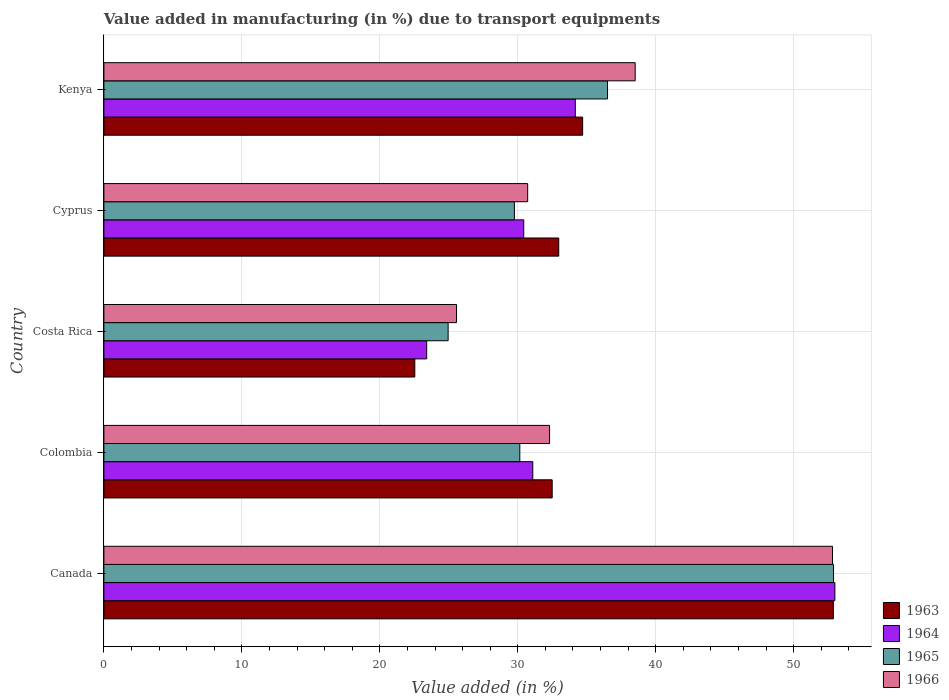Are the number of bars per tick equal to the number of legend labels?
Provide a short and direct response. Yes. How many bars are there on the 5th tick from the top?
Your answer should be very brief. 4. In how many cases, is the number of bars for a given country not equal to the number of legend labels?
Offer a terse response. 0. What is the percentage of value added in manufacturing due to transport equipments in 1965 in Kenya?
Offer a very short reply. 36.5. Across all countries, what is the maximum percentage of value added in manufacturing due to transport equipments in 1965?
Offer a terse response. 52.89. Across all countries, what is the minimum percentage of value added in manufacturing due to transport equipments in 1963?
Give a very brief answer. 22.53. What is the total percentage of value added in manufacturing due to transport equipments in 1965 in the graph?
Ensure brevity in your answer.  174.24. What is the difference between the percentage of value added in manufacturing due to transport equipments in 1965 in Canada and that in Kenya?
Your response must be concise. 16.38. What is the difference between the percentage of value added in manufacturing due to transport equipments in 1964 in Colombia and the percentage of value added in manufacturing due to transport equipments in 1965 in Kenya?
Your response must be concise. -5.42. What is the average percentage of value added in manufacturing due to transport equipments in 1966 per country?
Make the answer very short. 35.98. What is the difference between the percentage of value added in manufacturing due to transport equipments in 1963 and percentage of value added in manufacturing due to transport equipments in 1965 in Canada?
Your answer should be very brief. -0.01. In how many countries, is the percentage of value added in manufacturing due to transport equipments in 1963 greater than 10 %?
Keep it short and to the point. 5. What is the ratio of the percentage of value added in manufacturing due to transport equipments in 1966 in Canada to that in Kenya?
Your answer should be very brief. 1.37. Is the percentage of value added in manufacturing due to transport equipments in 1966 in Colombia less than that in Cyprus?
Offer a very short reply. No. What is the difference between the highest and the second highest percentage of value added in manufacturing due to transport equipments in 1965?
Offer a terse response. 16.38. What is the difference between the highest and the lowest percentage of value added in manufacturing due to transport equipments in 1966?
Provide a short and direct response. 27.25. In how many countries, is the percentage of value added in manufacturing due to transport equipments in 1965 greater than the average percentage of value added in manufacturing due to transport equipments in 1965 taken over all countries?
Offer a very short reply. 2. Is it the case that in every country, the sum of the percentage of value added in manufacturing due to transport equipments in 1965 and percentage of value added in manufacturing due to transport equipments in 1964 is greater than the sum of percentage of value added in manufacturing due to transport equipments in 1966 and percentage of value added in manufacturing due to transport equipments in 1963?
Your answer should be compact. No. What does the 3rd bar from the top in Costa Rica represents?
Give a very brief answer. 1964. What does the 3rd bar from the bottom in Canada represents?
Offer a terse response. 1965. Is it the case that in every country, the sum of the percentage of value added in manufacturing due to transport equipments in 1966 and percentage of value added in manufacturing due to transport equipments in 1963 is greater than the percentage of value added in manufacturing due to transport equipments in 1964?
Your response must be concise. Yes. Are all the bars in the graph horizontal?
Your answer should be compact. Yes. How many countries are there in the graph?
Ensure brevity in your answer.  5. Are the values on the major ticks of X-axis written in scientific E-notation?
Offer a terse response. No. Does the graph contain any zero values?
Keep it short and to the point. No. Does the graph contain grids?
Keep it short and to the point. Yes. Where does the legend appear in the graph?
Offer a very short reply. Bottom right. How many legend labels are there?
Ensure brevity in your answer.  4. How are the legend labels stacked?
Make the answer very short. Vertical. What is the title of the graph?
Make the answer very short. Value added in manufacturing (in %) due to transport equipments. What is the label or title of the X-axis?
Provide a succinct answer. Value added (in %). What is the Value added (in %) in 1963 in Canada?
Offer a very short reply. 52.87. What is the Value added (in %) of 1964 in Canada?
Provide a succinct answer. 52.98. What is the Value added (in %) in 1965 in Canada?
Make the answer very short. 52.89. What is the Value added (in %) of 1966 in Canada?
Offer a very short reply. 52.81. What is the Value added (in %) of 1963 in Colombia?
Your answer should be compact. 32.49. What is the Value added (in %) in 1964 in Colombia?
Your answer should be very brief. 31.09. What is the Value added (in %) of 1965 in Colombia?
Make the answer very short. 30.15. What is the Value added (in %) of 1966 in Colombia?
Provide a short and direct response. 32.3. What is the Value added (in %) of 1963 in Costa Rica?
Your answer should be compact. 22.53. What is the Value added (in %) in 1964 in Costa Rica?
Provide a short and direct response. 23.4. What is the Value added (in %) in 1965 in Costa Rica?
Provide a short and direct response. 24.95. What is the Value added (in %) of 1966 in Costa Rica?
Your answer should be very brief. 25.56. What is the Value added (in %) of 1963 in Cyprus?
Provide a short and direct response. 32.97. What is the Value added (in %) of 1964 in Cyprus?
Keep it short and to the point. 30.43. What is the Value added (in %) of 1965 in Cyprus?
Your answer should be very brief. 29.75. What is the Value added (in %) in 1966 in Cyprus?
Ensure brevity in your answer.  30.72. What is the Value added (in %) in 1963 in Kenya?
Make the answer very short. 34.7. What is the Value added (in %) of 1964 in Kenya?
Provide a succinct answer. 34.17. What is the Value added (in %) in 1965 in Kenya?
Ensure brevity in your answer.  36.5. What is the Value added (in %) of 1966 in Kenya?
Your answer should be very brief. 38.51. Across all countries, what is the maximum Value added (in %) in 1963?
Offer a very short reply. 52.87. Across all countries, what is the maximum Value added (in %) of 1964?
Provide a short and direct response. 52.98. Across all countries, what is the maximum Value added (in %) of 1965?
Your answer should be very brief. 52.89. Across all countries, what is the maximum Value added (in %) of 1966?
Your answer should be compact. 52.81. Across all countries, what is the minimum Value added (in %) in 1963?
Keep it short and to the point. 22.53. Across all countries, what is the minimum Value added (in %) of 1964?
Provide a succinct answer. 23.4. Across all countries, what is the minimum Value added (in %) in 1965?
Offer a very short reply. 24.95. Across all countries, what is the minimum Value added (in %) of 1966?
Offer a terse response. 25.56. What is the total Value added (in %) of 1963 in the graph?
Offer a very short reply. 175.57. What is the total Value added (in %) of 1964 in the graph?
Offer a very short reply. 172.06. What is the total Value added (in %) of 1965 in the graph?
Offer a terse response. 174.24. What is the total Value added (in %) of 1966 in the graph?
Ensure brevity in your answer.  179.9. What is the difference between the Value added (in %) of 1963 in Canada and that in Colombia?
Your answer should be compact. 20.38. What is the difference between the Value added (in %) of 1964 in Canada and that in Colombia?
Your answer should be compact. 21.9. What is the difference between the Value added (in %) of 1965 in Canada and that in Colombia?
Your answer should be compact. 22.74. What is the difference between the Value added (in %) of 1966 in Canada and that in Colombia?
Provide a succinct answer. 20.51. What is the difference between the Value added (in %) of 1963 in Canada and that in Costa Rica?
Ensure brevity in your answer.  30.34. What is the difference between the Value added (in %) of 1964 in Canada and that in Costa Rica?
Your answer should be very brief. 29.59. What is the difference between the Value added (in %) in 1965 in Canada and that in Costa Rica?
Your response must be concise. 27.93. What is the difference between the Value added (in %) of 1966 in Canada and that in Costa Rica?
Give a very brief answer. 27.25. What is the difference between the Value added (in %) in 1963 in Canada and that in Cyprus?
Your answer should be compact. 19.91. What is the difference between the Value added (in %) of 1964 in Canada and that in Cyprus?
Provide a succinct answer. 22.55. What is the difference between the Value added (in %) in 1965 in Canada and that in Cyprus?
Your answer should be very brief. 23.13. What is the difference between the Value added (in %) of 1966 in Canada and that in Cyprus?
Offer a terse response. 22.1. What is the difference between the Value added (in %) in 1963 in Canada and that in Kenya?
Offer a very short reply. 18.17. What is the difference between the Value added (in %) of 1964 in Canada and that in Kenya?
Your answer should be compact. 18.81. What is the difference between the Value added (in %) of 1965 in Canada and that in Kenya?
Offer a terse response. 16.38. What is the difference between the Value added (in %) in 1966 in Canada and that in Kenya?
Ensure brevity in your answer.  14.3. What is the difference between the Value added (in %) of 1963 in Colombia and that in Costa Rica?
Offer a very short reply. 9.96. What is the difference between the Value added (in %) of 1964 in Colombia and that in Costa Rica?
Keep it short and to the point. 7.69. What is the difference between the Value added (in %) of 1965 in Colombia and that in Costa Rica?
Your answer should be very brief. 5.2. What is the difference between the Value added (in %) of 1966 in Colombia and that in Costa Rica?
Keep it short and to the point. 6.74. What is the difference between the Value added (in %) of 1963 in Colombia and that in Cyprus?
Your answer should be very brief. -0.47. What is the difference between the Value added (in %) in 1964 in Colombia and that in Cyprus?
Your answer should be compact. 0.66. What is the difference between the Value added (in %) of 1965 in Colombia and that in Cyprus?
Your response must be concise. 0.39. What is the difference between the Value added (in %) in 1966 in Colombia and that in Cyprus?
Offer a very short reply. 1.59. What is the difference between the Value added (in %) of 1963 in Colombia and that in Kenya?
Ensure brevity in your answer.  -2.21. What is the difference between the Value added (in %) in 1964 in Colombia and that in Kenya?
Keep it short and to the point. -3.08. What is the difference between the Value added (in %) in 1965 in Colombia and that in Kenya?
Keep it short and to the point. -6.36. What is the difference between the Value added (in %) in 1966 in Colombia and that in Kenya?
Ensure brevity in your answer.  -6.2. What is the difference between the Value added (in %) of 1963 in Costa Rica and that in Cyprus?
Provide a succinct answer. -10.43. What is the difference between the Value added (in %) in 1964 in Costa Rica and that in Cyprus?
Ensure brevity in your answer.  -7.03. What is the difference between the Value added (in %) in 1965 in Costa Rica and that in Cyprus?
Keep it short and to the point. -4.8. What is the difference between the Value added (in %) of 1966 in Costa Rica and that in Cyprus?
Your response must be concise. -5.16. What is the difference between the Value added (in %) of 1963 in Costa Rica and that in Kenya?
Make the answer very short. -12.17. What is the difference between the Value added (in %) of 1964 in Costa Rica and that in Kenya?
Your answer should be compact. -10.77. What is the difference between the Value added (in %) in 1965 in Costa Rica and that in Kenya?
Make the answer very short. -11.55. What is the difference between the Value added (in %) in 1966 in Costa Rica and that in Kenya?
Give a very brief answer. -12.95. What is the difference between the Value added (in %) of 1963 in Cyprus and that in Kenya?
Offer a terse response. -1.73. What is the difference between the Value added (in %) of 1964 in Cyprus and that in Kenya?
Offer a terse response. -3.74. What is the difference between the Value added (in %) in 1965 in Cyprus and that in Kenya?
Keep it short and to the point. -6.75. What is the difference between the Value added (in %) of 1966 in Cyprus and that in Kenya?
Offer a very short reply. -7.79. What is the difference between the Value added (in %) in 1963 in Canada and the Value added (in %) in 1964 in Colombia?
Your answer should be very brief. 21.79. What is the difference between the Value added (in %) of 1963 in Canada and the Value added (in %) of 1965 in Colombia?
Offer a terse response. 22.73. What is the difference between the Value added (in %) in 1963 in Canada and the Value added (in %) in 1966 in Colombia?
Offer a very short reply. 20.57. What is the difference between the Value added (in %) of 1964 in Canada and the Value added (in %) of 1965 in Colombia?
Your answer should be very brief. 22.84. What is the difference between the Value added (in %) of 1964 in Canada and the Value added (in %) of 1966 in Colombia?
Offer a terse response. 20.68. What is the difference between the Value added (in %) in 1965 in Canada and the Value added (in %) in 1966 in Colombia?
Ensure brevity in your answer.  20.58. What is the difference between the Value added (in %) of 1963 in Canada and the Value added (in %) of 1964 in Costa Rica?
Give a very brief answer. 29.48. What is the difference between the Value added (in %) of 1963 in Canada and the Value added (in %) of 1965 in Costa Rica?
Your answer should be very brief. 27.92. What is the difference between the Value added (in %) of 1963 in Canada and the Value added (in %) of 1966 in Costa Rica?
Give a very brief answer. 27.31. What is the difference between the Value added (in %) of 1964 in Canada and the Value added (in %) of 1965 in Costa Rica?
Your answer should be compact. 28.03. What is the difference between the Value added (in %) of 1964 in Canada and the Value added (in %) of 1966 in Costa Rica?
Provide a succinct answer. 27.42. What is the difference between the Value added (in %) in 1965 in Canada and the Value added (in %) in 1966 in Costa Rica?
Your answer should be compact. 27.33. What is the difference between the Value added (in %) in 1963 in Canada and the Value added (in %) in 1964 in Cyprus?
Your answer should be very brief. 22.44. What is the difference between the Value added (in %) in 1963 in Canada and the Value added (in %) in 1965 in Cyprus?
Provide a short and direct response. 23.12. What is the difference between the Value added (in %) of 1963 in Canada and the Value added (in %) of 1966 in Cyprus?
Your response must be concise. 22.16. What is the difference between the Value added (in %) of 1964 in Canada and the Value added (in %) of 1965 in Cyprus?
Your answer should be compact. 23.23. What is the difference between the Value added (in %) of 1964 in Canada and the Value added (in %) of 1966 in Cyprus?
Offer a very short reply. 22.27. What is the difference between the Value added (in %) of 1965 in Canada and the Value added (in %) of 1966 in Cyprus?
Your answer should be compact. 22.17. What is the difference between the Value added (in %) of 1963 in Canada and the Value added (in %) of 1964 in Kenya?
Your response must be concise. 18.7. What is the difference between the Value added (in %) in 1963 in Canada and the Value added (in %) in 1965 in Kenya?
Ensure brevity in your answer.  16.37. What is the difference between the Value added (in %) in 1963 in Canada and the Value added (in %) in 1966 in Kenya?
Your answer should be compact. 14.37. What is the difference between the Value added (in %) in 1964 in Canada and the Value added (in %) in 1965 in Kenya?
Ensure brevity in your answer.  16.48. What is the difference between the Value added (in %) in 1964 in Canada and the Value added (in %) in 1966 in Kenya?
Make the answer very short. 14.47. What is the difference between the Value added (in %) of 1965 in Canada and the Value added (in %) of 1966 in Kenya?
Offer a very short reply. 14.38. What is the difference between the Value added (in %) in 1963 in Colombia and the Value added (in %) in 1964 in Costa Rica?
Provide a succinct answer. 9.1. What is the difference between the Value added (in %) of 1963 in Colombia and the Value added (in %) of 1965 in Costa Rica?
Offer a very short reply. 7.54. What is the difference between the Value added (in %) in 1963 in Colombia and the Value added (in %) in 1966 in Costa Rica?
Provide a succinct answer. 6.93. What is the difference between the Value added (in %) of 1964 in Colombia and the Value added (in %) of 1965 in Costa Rica?
Your answer should be compact. 6.14. What is the difference between the Value added (in %) in 1964 in Colombia and the Value added (in %) in 1966 in Costa Rica?
Ensure brevity in your answer.  5.53. What is the difference between the Value added (in %) of 1965 in Colombia and the Value added (in %) of 1966 in Costa Rica?
Provide a short and direct response. 4.59. What is the difference between the Value added (in %) in 1963 in Colombia and the Value added (in %) in 1964 in Cyprus?
Offer a terse response. 2.06. What is the difference between the Value added (in %) of 1963 in Colombia and the Value added (in %) of 1965 in Cyprus?
Make the answer very short. 2.74. What is the difference between the Value added (in %) in 1963 in Colombia and the Value added (in %) in 1966 in Cyprus?
Make the answer very short. 1.78. What is the difference between the Value added (in %) of 1964 in Colombia and the Value added (in %) of 1965 in Cyprus?
Your answer should be compact. 1.33. What is the difference between the Value added (in %) in 1964 in Colombia and the Value added (in %) in 1966 in Cyprus?
Keep it short and to the point. 0.37. What is the difference between the Value added (in %) in 1965 in Colombia and the Value added (in %) in 1966 in Cyprus?
Offer a very short reply. -0.57. What is the difference between the Value added (in %) of 1963 in Colombia and the Value added (in %) of 1964 in Kenya?
Offer a very short reply. -1.68. What is the difference between the Value added (in %) in 1963 in Colombia and the Value added (in %) in 1965 in Kenya?
Offer a very short reply. -4.01. What is the difference between the Value added (in %) of 1963 in Colombia and the Value added (in %) of 1966 in Kenya?
Ensure brevity in your answer.  -6.01. What is the difference between the Value added (in %) of 1964 in Colombia and the Value added (in %) of 1965 in Kenya?
Your answer should be very brief. -5.42. What is the difference between the Value added (in %) in 1964 in Colombia and the Value added (in %) in 1966 in Kenya?
Offer a terse response. -7.42. What is the difference between the Value added (in %) of 1965 in Colombia and the Value added (in %) of 1966 in Kenya?
Give a very brief answer. -8.36. What is the difference between the Value added (in %) of 1963 in Costa Rica and the Value added (in %) of 1964 in Cyprus?
Your response must be concise. -7.9. What is the difference between the Value added (in %) in 1963 in Costa Rica and the Value added (in %) in 1965 in Cyprus?
Your response must be concise. -7.22. What is the difference between the Value added (in %) of 1963 in Costa Rica and the Value added (in %) of 1966 in Cyprus?
Offer a very short reply. -8.18. What is the difference between the Value added (in %) in 1964 in Costa Rica and the Value added (in %) in 1965 in Cyprus?
Keep it short and to the point. -6.36. What is the difference between the Value added (in %) in 1964 in Costa Rica and the Value added (in %) in 1966 in Cyprus?
Provide a succinct answer. -7.32. What is the difference between the Value added (in %) of 1965 in Costa Rica and the Value added (in %) of 1966 in Cyprus?
Keep it short and to the point. -5.77. What is the difference between the Value added (in %) in 1963 in Costa Rica and the Value added (in %) in 1964 in Kenya?
Make the answer very short. -11.64. What is the difference between the Value added (in %) in 1963 in Costa Rica and the Value added (in %) in 1965 in Kenya?
Make the answer very short. -13.97. What is the difference between the Value added (in %) of 1963 in Costa Rica and the Value added (in %) of 1966 in Kenya?
Give a very brief answer. -15.97. What is the difference between the Value added (in %) of 1964 in Costa Rica and the Value added (in %) of 1965 in Kenya?
Offer a very short reply. -13.11. What is the difference between the Value added (in %) of 1964 in Costa Rica and the Value added (in %) of 1966 in Kenya?
Make the answer very short. -15.11. What is the difference between the Value added (in %) of 1965 in Costa Rica and the Value added (in %) of 1966 in Kenya?
Ensure brevity in your answer.  -13.56. What is the difference between the Value added (in %) of 1963 in Cyprus and the Value added (in %) of 1964 in Kenya?
Provide a succinct answer. -1.2. What is the difference between the Value added (in %) in 1963 in Cyprus and the Value added (in %) in 1965 in Kenya?
Your answer should be compact. -3.54. What is the difference between the Value added (in %) of 1963 in Cyprus and the Value added (in %) of 1966 in Kenya?
Provide a short and direct response. -5.54. What is the difference between the Value added (in %) in 1964 in Cyprus and the Value added (in %) in 1965 in Kenya?
Give a very brief answer. -6.07. What is the difference between the Value added (in %) of 1964 in Cyprus and the Value added (in %) of 1966 in Kenya?
Keep it short and to the point. -8.08. What is the difference between the Value added (in %) of 1965 in Cyprus and the Value added (in %) of 1966 in Kenya?
Provide a short and direct response. -8.75. What is the average Value added (in %) of 1963 per country?
Offer a very short reply. 35.11. What is the average Value added (in %) in 1964 per country?
Your answer should be compact. 34.41. What is the average Value added (in %) in 1965 per country?
Your answer should be very brief. 34.85. What is the average Value added (in %) of 1966 per country?
Provide a succinct answer. 35.98. What is the difference between the Value added (in %) of 1963 and Value added (in %) of 1964 in Canada?
Provide a succinct answer. -0.11. What is the difference between the Value added (in %) in 1963 and Value added (in %) in 1965 in Canada?
Offer a very short reply. -0.01. What is the difference between the Value added (in %) in 1963 and Value added (in %) in 1966 in Canada?
Your answer should be compact. 0.06. What is the difference between the Value added (in %) of 1964 and Value added (in %) of 1965 in Canada?
Your answer should be very brief. 0.1. What is the difference between the Value added (in %) of 1964 and Value added (in %) of 1966 in Canada?
Your answer should be compact. 0.17. What is the difference between the Value added (in %) in 1965 and Value added (in %) in 1966 in Canada?
Provide a succinct answer. 0.07. What is the difference between the Value added (in %) of 1963 and Value added (in %) of 1964 in Colombia?
Ensure brevity in your answer.  1.41. What is the difference between the Value added (in %) in 1963 and Value added (in %) in 1965 in Colombia?
Offer a terse response. 2.35. What is the difference between the Value added (in %) of 1963 and Value added (in %) of 1966 in Colombia?
Your answer should be compact. 0.19. What is the difference between the Value added (in %) in 1964 and Value added (in %) in 1965 in Colombia?
Make the answer very short. 0.94. What is the difference between the Value added (in %) in 1964 and Value added (in %) in 1966 in Colombia?
Offer a terse response. -1.22. What is the difference between the Value added (in %) of 1965 and Value added (in %) of 1966 in Colombia?
Make the answer very short. -2.16. What is the difference between the Value added (in %) of 1963 and Value added (in %) of 1964 in Costa Rica?
Your response must be concise. -0.86. What is the difference between the Value added (in %) in 1963 and Value added (in %) in 1965 in Costa Rica?
Keep it short and to the point. -2.42. What is the difference between the Value added (in %) in 1963 and Value added (in %) in 1966 in Costa Rica?
Keep it short and to the point. -3.03. What is the difference between the Value added (in %) in 1964 and Value added (in %) in 1965 in Costa Rica?
Your answer should be compact. -1.55. What is the difference between the Value added (in %) in 1964 and Value added (in %) in 1966 in Costa Rica?
Offer a terse response. -2.16. What is the difference between the Value added (in %) of 1965 and Value added (in %) of 1966 in Costa Rica?
Ensure brevity in your answer.  -0.61. What is the difference between the Value added (in %) of 1963 and Value added (in %) of 1964 in Cyprus?
Your response must be concise. 2.54. What is the difference between the Value added (in %) of 1963 and Value added (in %) of 1965 in Cyprus?
Provide a succinct answer. 3.21. What is the difference between the Value added (in %) of 1963 and Value added (in %) of 1966 in Cyprus?
Give a very brief answer. 2.25. What is the difference between the Value added (in %) in 1964 and Value added (in %) in 1965 in Cyprus?
Offer a terse response. 0.68. What is the difference between the Value added (in %) in 1964 and Value added (in %) in 1966 in Cyprus?
Provide a succinct answer. -0.29. What is the difference between the Value added (in %) of 1965 and Value added (in %) of 1966 in Cyprus?
Your response must be concise. -0.96. What is the difference between the Value added (in %) in 1963 and Value added (in %) in 1964 in Kenya?
Ensure brevity in your answer.  0.53. What is the difference between the Value added (in %) in 1963 and Value added (in %) in 1965 in Kenya?
Provide a short and direct response. -1.8. What is the difference between the Value added (in %) in 1963 and Value added (in %) in 1966 in Kenya?
Your response must be concise. -3.81. What is the difference between the Value added (in %) of 1964 and Value added (in %) of 1965 in Kenya?
Keep it short and to the point. -2.33. What is the difference between the Value added (in %) in 1964 and Value added (in %) in 1966 in Kenya?
Your response must be concise. -4.34. What is the difference between the Value added (in %) in 1965 and Value added (in %) in 1966 in Kenya?
Your answer should be very brief. -2. What is the ratio of the Value added (in %) of 1963 in Canada to that in Colombia?
Provide a short and direct response. 1.63. What is the ratio of the Value added (in %) of 1964 in Canada to that in Colombia?
Provide a short and direct response. 1.7. What is the ratio of the Value added (in %) in 1965 in Canada to that in Colombia?
Provide a succinct answer. 1.75. What is the ratio of the Value added (in %) in 1966 in Canada to that in Colombia?
Offer a very short reply. 1.63. What is the ratio of the Value added (in %) of 1963 in Canada to that in Costa Rica?
Give a very brief answer. 2.35. What is the ratio of the Value added (in %) in 1964 in Canada to that in Costa Rica?
Provide a short and direct response. 2.26. What is the ratio of the Value added (in %) of 1965 in Canada to that in Costa Rica?
Provide a short and direct response. 2.12. What is the ratio of the Value added (in %) in 1966 in Canada to that in Costa Rica?
Keep it short and to the point. 2.07. What is the ratio of the Value added (in %) in 1963 in Canada to that in Cyprus?
Offer a very short reply. 1.6. What is the ratio of the Value added (in %) of 1964 in Canada to that in Cyprus?
Your answer should be compact. 1.74. What is the ratio of the Value added (in %) of 1965 in Canada to that in Cyprus?
Provide a succinct answer. 1.78. What is the ratio of the Value added (in %) of 1966 in Canada to that in Cyprus?
Keep it short and to the point. 1.72. What is the ratio of the Value added (in %) in 1963 in Canada to that in Kenya?
Ensure brevity in your answer.  1.52. What is the ratio of the Value added (in %) in 1964 in Canada to that in Kenya?
Make the answer very short. 1.55. What is the ratio of the Value added (in %) in 1965 in Canada to that in Kenya?
Your answer should be compact. 1.45. What is the ratio of the Value added (in %) in 1966 in Canada to that in Kenya?
Give a very brief answer. 1.37. What is the ratio of the Value added (in %) of 1963 in Colombia to that in Costa Rica?
Your answer should be compact. 1.44. What is the ratio of the Value added (in %) of 1964 in Colombia to that in Costa Rica?
Ensure brevity in your answer.  1.33. What is the ratio of the Value added (in %) in 1965 in Colombia to that in Costa Rica?
Your answer should be compact. 1.21. What is the ratio of the Value added (in %) in 1966 in Colombia to that in Costa Rica?
Give a very brief answer. 1.26. What is the ratio of the Value added (in %) in 1963 in Colombia to that in Cyprus?
Offer a very short reply. 0.99. What is the ratio of the Value added (in %) in 1964 in Colombia to that in Cyprus?
Your answer should be very brief. 1.02. What is the ratio of the Value added (in %) of 1965 in Colombia to that in Cyprus?
Your response must be concise. 1.01. What is the ratio of the Value added (in %) in 1966 in Colombia to that in Cyprus?
Give a very brief answer. 1.05. What is the ratio of the Value added (in %) of 1963 in Colombia to that in Kenya?
Give a very brief answer. 0.94. What is the ratio of the Value added (in %) in 1964 in Colombia to that in Kenya?
Offer a terse response. 0.91. What is the ratio of the Value added (in %) in 1965 in Colombia to that in Kenya?
Ensure brevity in your answer.  0.83. What is the ratio of the Value added (in %) in 1966 in Colombia to that in Kenya?
Keep it short and to the point. 0.84. What is the ratio of the Value added (in %) in 1963 in Costa Rica to that in Cyprus?
Make the answer very short. 0.68. What is the ratio of the Value added (in %) of 1964 in Costa Rica to that in Cyprus?
Your response must be concise. 0.77. What is the ratio of the Value added (in %) in 1965 in Costa Rica to that in Cyprus?
Offer a very short reply. 0.84. What is the ratio of the Value added (in %) of 1966 in Costa Rica to that in Cyprus?
Make the answer very short. 0.83. What is the ratio of the Value added (in %) in 1963 in Costa Rica to that in Kenya?
Your answer should be compact. 0.65. What is the ratio of the Value added (in %) in 1964 in Costa Rica to that in Kenya?
Your response must be concise. 0.68. What is the ratio of the Value added (in %) of 1965 in Costa Rica to that in Kenya?
Make the answer very short. 0.68. What is the ratio of the Value added (in %) of 1966 in Costa Rica to that in Kenya?
Your answer should be very brief. 0.66. What is the ratio of the Value added (in %) of 1963 in Cyprus to that in Kenya?
Keep it short and to the point. 0.95. What is the ratio of the Value added (in %) of 1964 in Cyprus to that in Kenya?
Your response must be concise. 0.89. What is the ratio of the Value added (in %) of 1965 in Cyprus to that in Kenya?
Ensure brevity in your answer.  0.82. What is the ratio of the Value added (in %) of 1966 in Cyprus to that in Kenya?
Give a very brief answer. 0.8. What is the difference between the highest and the second highest Value added (in %) in 1963?
Your answer should be very brief. 18.17. What is the difference between the highest and the second highest Value added (in %) in 1964?
Provide a succinct answer. 18.81. What is the difference between the highest and the second highest Value added (in %) in 1965?
Provide a succinct answer. 16.38. What is the difference between the highest and the second highest Value added (in %) in 1966?
Your response must be concise. 14.3. What is the difference between the highest and the lowest Value added (in %) of 1963?
Make the answer very short. 30.34. What is the difference between the highest and the lowest Value added (in %) in 1964?
Offer a terse response. 29.59. What is the difference between the highest and the lowest Value added (in %) in 1965?
Ensure brevity in your answer.  27.93. What is the difference between the highest and the lowest Value added (in %) of 1966?
Your answer should be very brief. 27.25. 